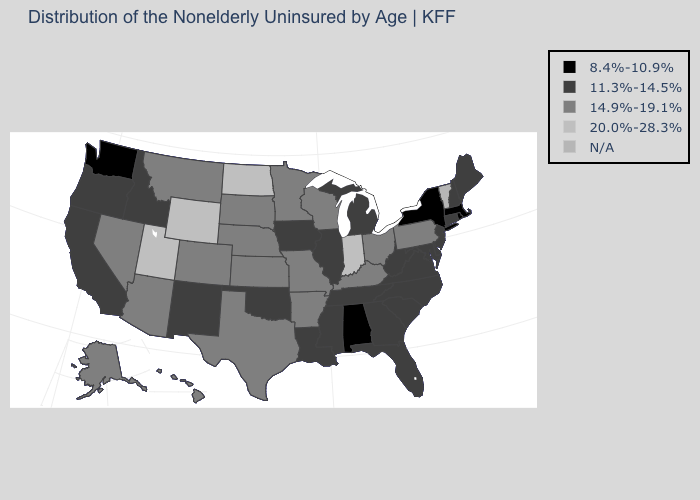Name the states that have a value in the range N/A?
Keep it brief. Vermont. How many symbols are there in the legend?
Be succinct. 5. What is the value of Indiana?
Answer briefly. 20.0%-28.3%. Name the states that have a value in the range N/A?
Concise answer only. Vermont. How many symbols are there in the legend?
Be succinct. 5. Name the states that have a value in the range N/A?
Keep it brief. Vermont. Name the states that have a value in the range 14.9%-19.1%?
Short answer required. Alaska, Arizona, Arkansas, Colorado, Hawaii, Kansas, Kentucky, Minnesota, Missouri, Montana, Nebraska, Nevada, Ohio, Pennsylvania, South Dakota, Texas, Wisconsin. Name the states that have a value in the range N/A?
Write a very short answer. Vermont. What is the value of Kansas?
Short answer required. 14.9%-19.1%. What is the value of Massachusetts?
Short answer required. 8.4%-10.9%. Which states have the lowest value in the Northeast?
Write a very short answer. Massachusetts, New York, Rhode Island. What is the highest value in the USA?
Write a very short answer. 20.0%-28.3%. What is the lowest value in the USA?
Answer briefly. 8.4%-10.9%. 